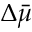Convert formula to latex. <formula><loc_0><loc_0><loc_500><loc_500>\Delta \bar { \mu }</formula> 